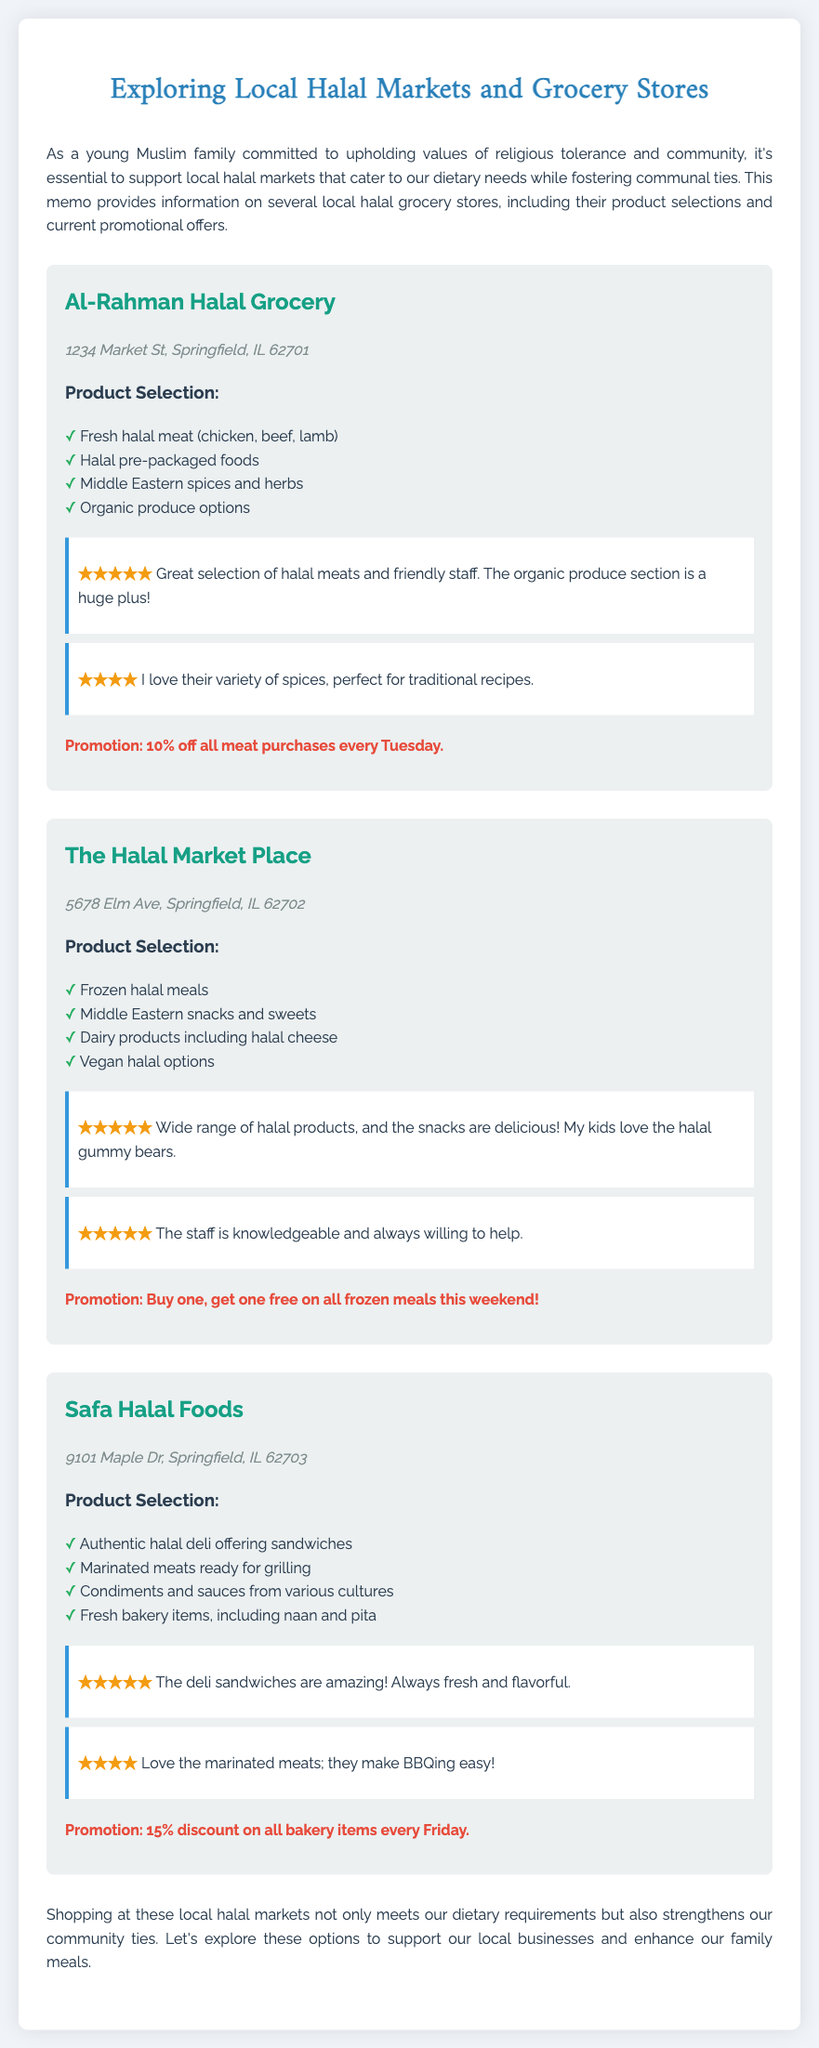What is the address of Al-Rahman Halal Grocery? The address is located in the document under the store listing for Al-Rahman Halal Grocery.
Answer: 1234 Market St, Springfield, IL 62701 What promotion is offered by The Halal Market Place? The promotion is mentioned in the store details for The Halal Market Place, indicating a specific offer.
Answer: Buy one, get one free on all frozen meals this weekend! How many products are listed for Safa Halal Foods? The document details the product selection for Safa Halal Foods, listing each item clearly.
Answer: Four Which store has a promotion for 15% discount on bakery items? The promotion details are included under the store listing, allowing for identification of the specific store.
Answer: Safa Halal Foods What did a customer say about Al-Rahman Halal Grocery's organic produce? The customer's feedback provides insight into product quality and the shopping experience at Al-Rahman Halal Grocery.
Answer: Huge plus Which type of meat does Al-Rahman Halal Grocery offer? The product selection outlines the specific types of meat available at this grocery store.
Answer: Chicken, beef, lamb Which halal grocery store is described as having delicious snacks for kids? The document contains reviews that highlight specific features and products appealing to families.
Answer: The Halal Market Place What is a common feature across all the listed halal grocery stores? The document emphasizes the importance of community support and shared values in the context of shopping at these stores.
Answer: Halal products 